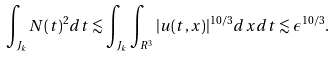Convert formula to latex. <formula><loc_0><loc_0><loc_500><loc_500>\int _ { J _ { k } } N ( t ) ^ { 2 } d t \lesssim \int _ { J _ { k } } \int _ { R ^ { 3 } } | u ( t , x ) | ^ { 1 0 / 3 } d x d t \lesssim \epsilon ^ { 1 0 / 3 } .</formula> 